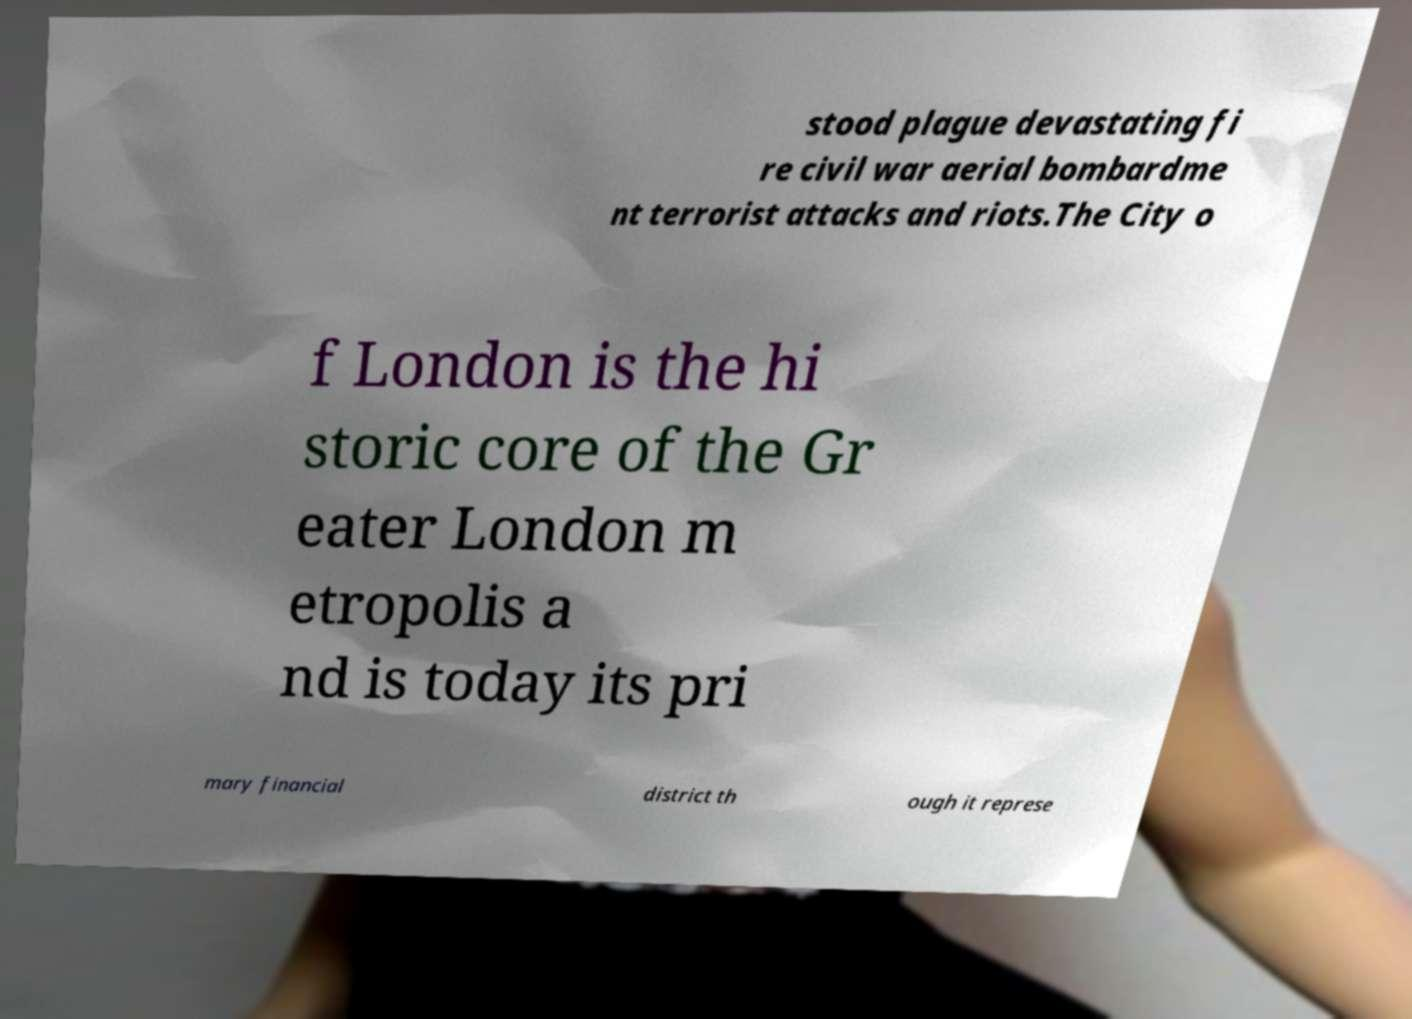For documentation purposes, I need the text within this image transcribed. Could you provide that? stood plague devastating fi re civil war aerial bombardme nt terrorist attacks and riots.The City o f London is the hi storic core of the Gr eater London m etropolis a nd is today its pri mary financial district th ough it represe 